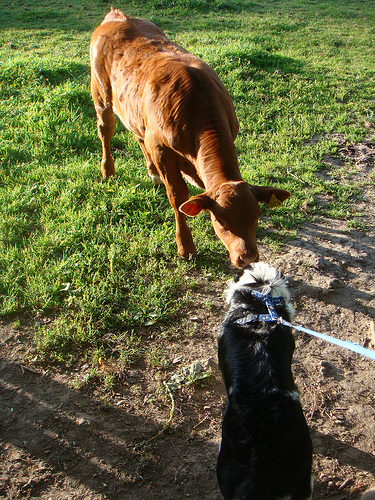<image>
Is the dog on the grass? Yes. Looking at the image, I can see the dog is positioned on top of the grass, with the grass providing support. 